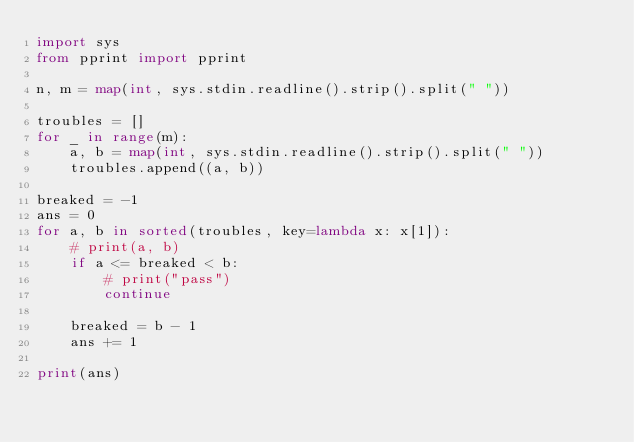Convert code to text. <code><loc_0><loc_0><loc_500><loc_500><_Python_>import sys
from pprint import pprint

n, m = map(int, sys.stdin.readline().strip().split(" "))

troubles = []
for _ in range(m):
    a, b = map(int, sys.stdin.readline().strip().split(" "))
    troubles.append((a, b))

breaked = -1
ans = 0
for a, b in sorted(troubles, key=lambda x: x[1]):
    # print(a, b)
    if a <= breaked < b:
        # print("pass")
        continue

    breaked = b - 1
    ans += 1

print(ans)</code> 